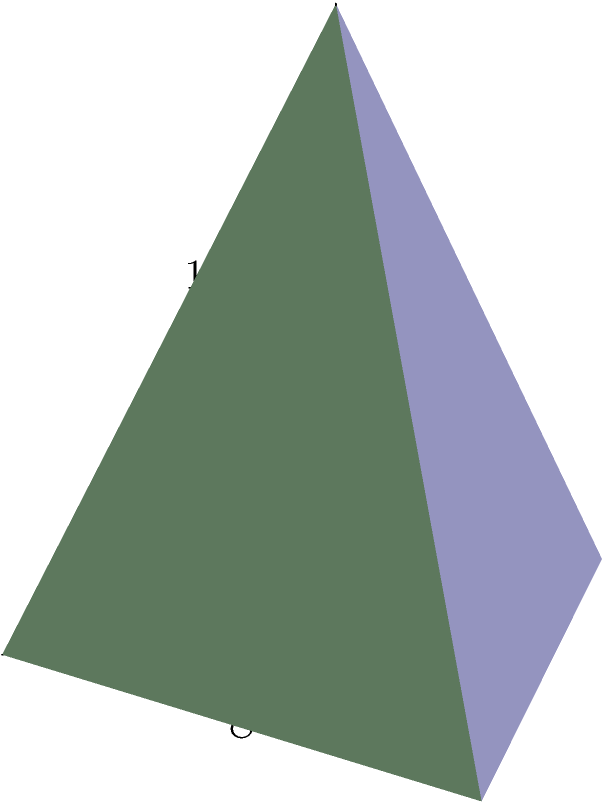As a podcaster exploring the intersection of history and marketing, you're discussing ancient Egyptian pyramids and their use in early brand marketing. To illustrate the scale of these structures, you want to calculate the volume of a pyramid with a square base. If the base of the pyramid measures 8 meters on each side and the height of the pyramid is 10 meters, what is the volume of the pyramid in cubic meters? To calculate the volume of a pyramid with a square base, we can use the formula:

$$V = \frac{1}{3} \times B \times h$$

Where:
$V$ = Volume of the pyramid
$B$ = Area of the base
$h$ = Height of the pyramid

Let's solve this step-by-step:

1. Calculate the area of the base ($B$):
   The base is a square with side length 8 meters.
   $$B = 8 \text{ m} \times 8 \text{ m} = 64 \text{ m}^2$$

2. We're given the height ($h$) of the pyramid:
   $$h = 10 \text{ m}$$

3. Now, let's substitute these values into our volume formula:
   $$V = \frac{1}{3} \times B \times h$$
   $$V = \frac{1}{3} \times 64 \text{ m}^2 \times 10 \text{ m}$$

4. Calculate the result:
   $$V = \frac{640}{3} \text{ m}^3 \approx 213.33 \text{ m}^3$$

Therefore, the volume of the pyramid is approximately 213.33 cubic meters.
Answer: 213.33 m³ 